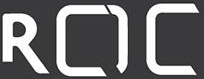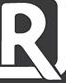Identify the words shown in these images in order, separated by a semicolon. ROC; R 